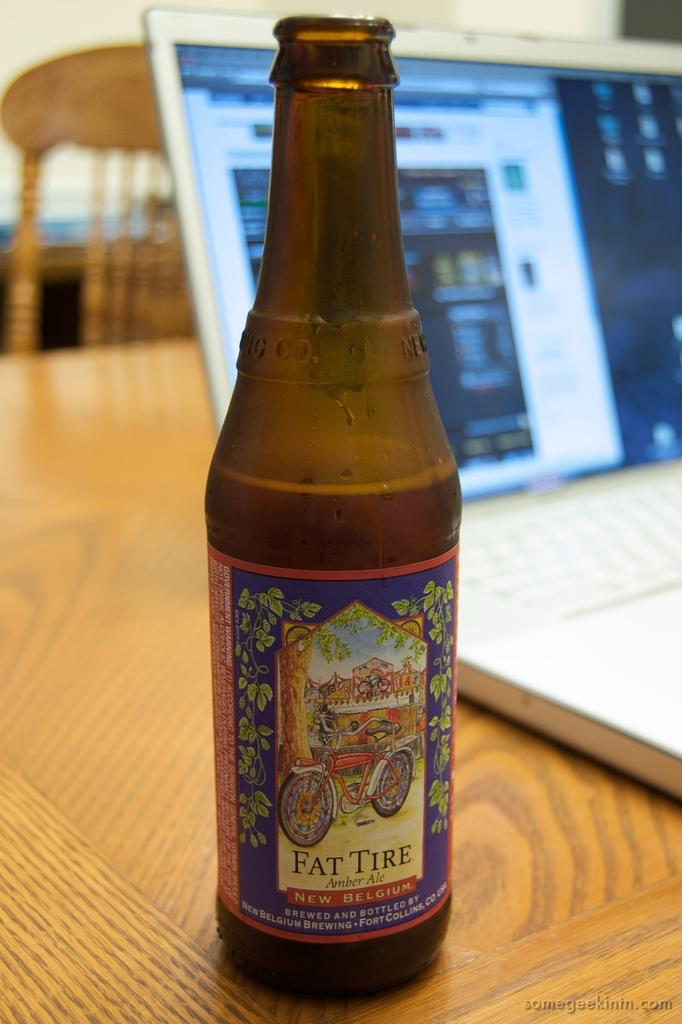<image>
Describe the image concisely. a bottle of Fat Tire Amber ale on a table 